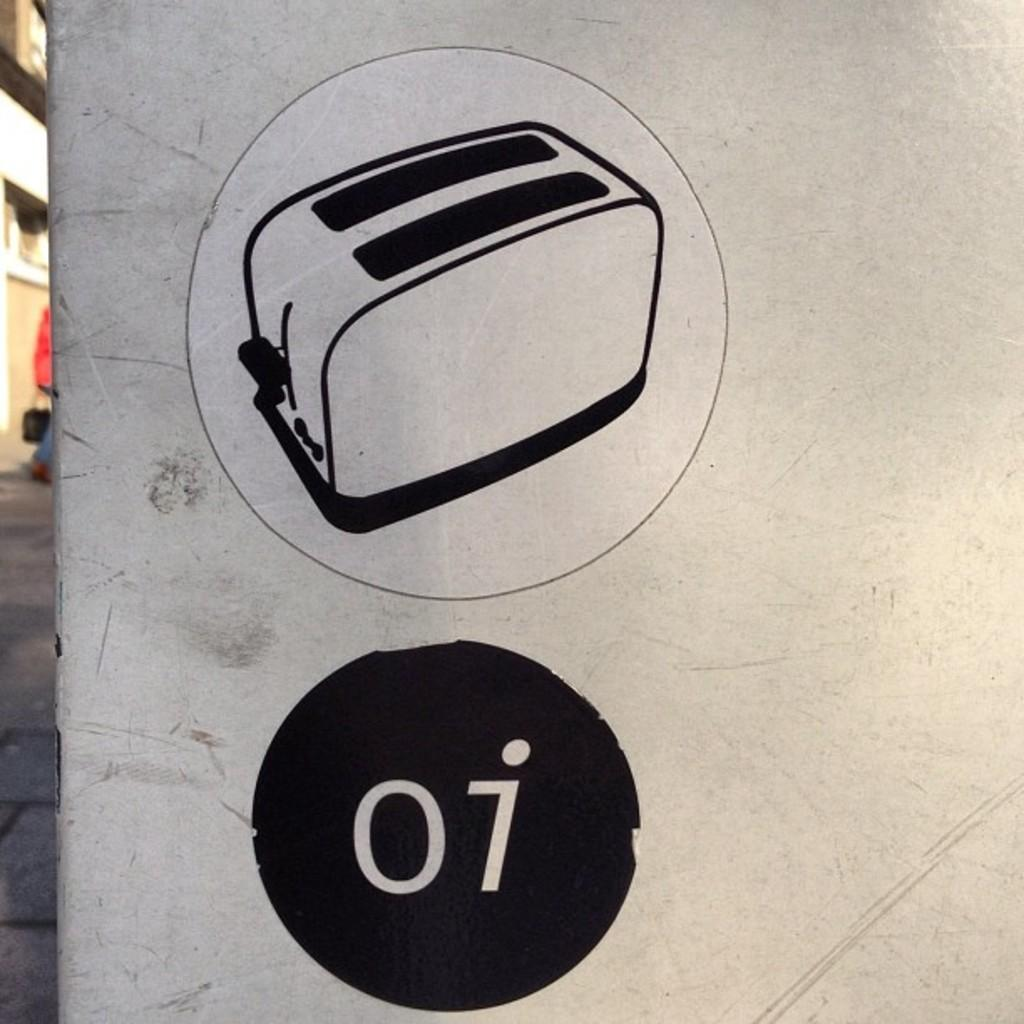What is the main feature of the image? There is a logo in the image. What type of image is present alongside the logo? There is a black and white picture of a building in the image. Can you describe the person in the image? There is a person on the left side of the image. Reasoning: Let' Let's think step by step in order to produce the conversation. We start by identifying the main feature of the image, which is the logo. Then, we describe the other elements present in the image, such as the black and white picture of a building and the person on the left side. Each question is designed to elicit a specific detail about the image that is known from the provided facts. Absurd Question/Answer: What type of bat is flying in the image? There is no bat present in the image. What selection process is being depicted in the image? The image does not depict a selection process; it features a logo, a black and white picture of a building, and a person. How is the glue being used in the image? There is no glue present in the image. What type of creature is shown interacting with the building in the image? The image does not depict any creatures interacting with the building; it features a logo, a black and white picture of a building, and a person. 